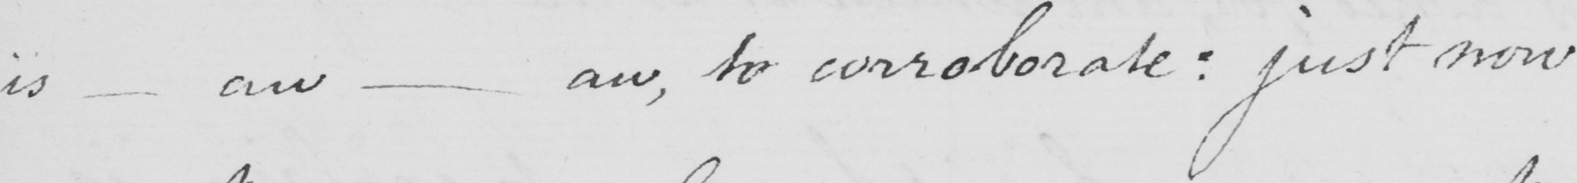Please transcribe the handwritten text in this image. is  _  aw  _  aw , to corroborate :  just now 